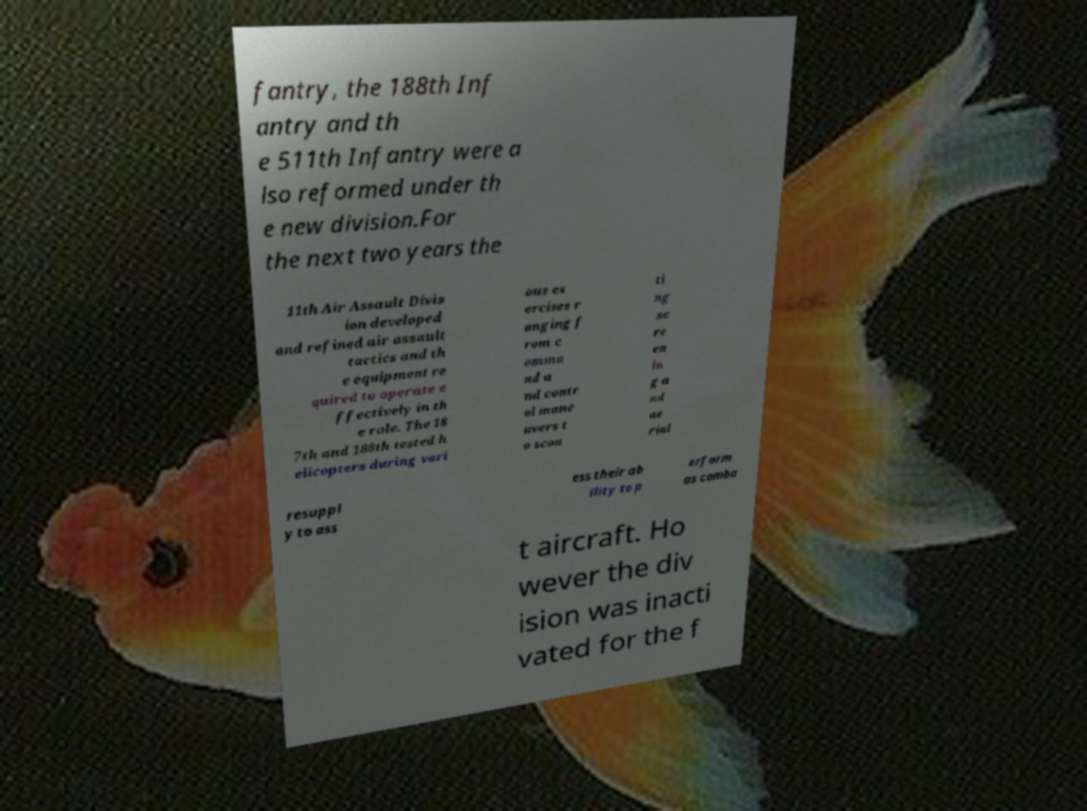Please read and relay the text visible in this image. What does it say? fantry, the 188th Inf antry and th e 511th Infantry were a lso reformed under th e new division.For the next two years the 11th Air Assault Divis ion developed and refined air assault tactics and th e equipment re quired to operate e ffectively in th e role. The 18 7th and 188th tested h elicopters during vari ous ex ercises r anging f rom c omma nd a nd contr ol mane uvers t o scou ti ng sc re en in g a nd ae rial resuppl y to ass ess their ab ility to p erform as comba t aircraft. Ho wever the div ision was inacti vated for the f 